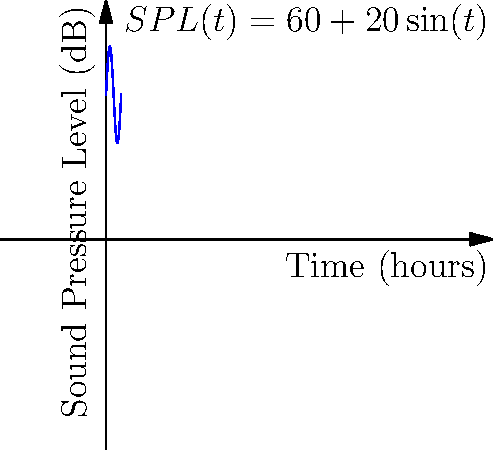Consider the sound pressure level (SPL) function $SPL(t) = 60 + 20\sin(t)$ dB, where $t$ is measured in hours. Calculate the cumulative noise exposure over a 6-hour period (from $t=0$ to $t=2\pi$). How does this result relate to the concept of noise dosage in acoustic philosophy? To solve this problem, we need to follow these steps:

1) The cumulative noise exposure is represented by the integral of the SPL function over the given time period:

   $\int_0^{2\pi} (60 + 20\sin(t)) dt$

2) We can split this integral:

   $\int_0^{2\pi} 60 dt + \int_0^{2\pi} 20\sin(t) dt$

3) For the first part:
   $\int_0^{2\pi} 60 dt = 60t \big|_0^{2\pi} = 60(2\pi - 0) = 120\pi$

4) For the second part:
   $\int_0^{2\pi} 20\sin(t) dt = -20\cos(t) \big|_0^{2\pi} = -20(\cos(2\pi) - \cos(0)) = 0$

5) Adding the results:
   $120\pi + 0 = 120\pi$ dB-hours

6) This result represents the total noise exposure over the 6-hour period. In acoustic philosophy, this concept relates to noise dosage, which is the accumulated exposure to sound over time. It's crucial for understanding the long-term effects of noise on human perception and well-being.

7) The average SPL over this period is $120\pi / (2\pi) = 60$ dB, which coincides with the constant term in the original function. This illustrates how periodic fluctuations in sound levels can be averaged out over time, potentially masking the variability in actual exposure.
Answer: $120\pi$ dB-hours 